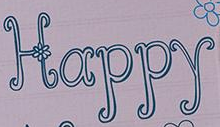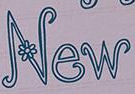Identify the words shown in these images in order, separated by a semicolon. Happy; New 